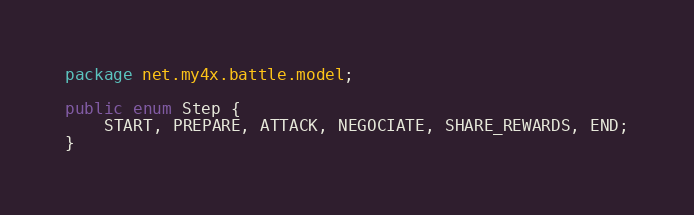Convert code to text. <code><loc_0><loc_0><loc_500><loc_500><_Java_>package net.my4x.battle.model;

public enum Step {
	START, PREPARE, ATTACK, NEGOCIATE, SHARE_REWARDS, END;
}
</code> 